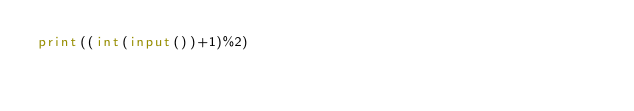Convert code to text. <code><loc_0><loc_0><loc_500><loc_500><_Python_>print((int(input())+1)%2)</code> 